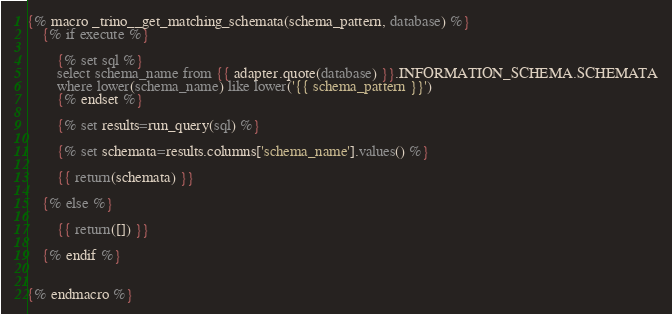<code> <loc_0><loc_0><loc_500><loc_500><_SQL_>

{% macro _trino__get_matching_schemata(schema_pattern, database) %}
    {% if execute %}

        {% set sql %}
        select schema_name from {{ adapter.quote(database) }}.INFORMATION_SCHEMA.SCHEMATA
        where lower(schema_name) like lower('{{ schema_pattern }}')
        {% endset %}

        {% set results=run_query(sql) %}

        {% set schemata=results.columns['schema_name'].values() %}

        {{ return(schemata) }}

    {% else %}

        {{ return([]) }}

    {% endif %}


{% endmacro %}
</code> 